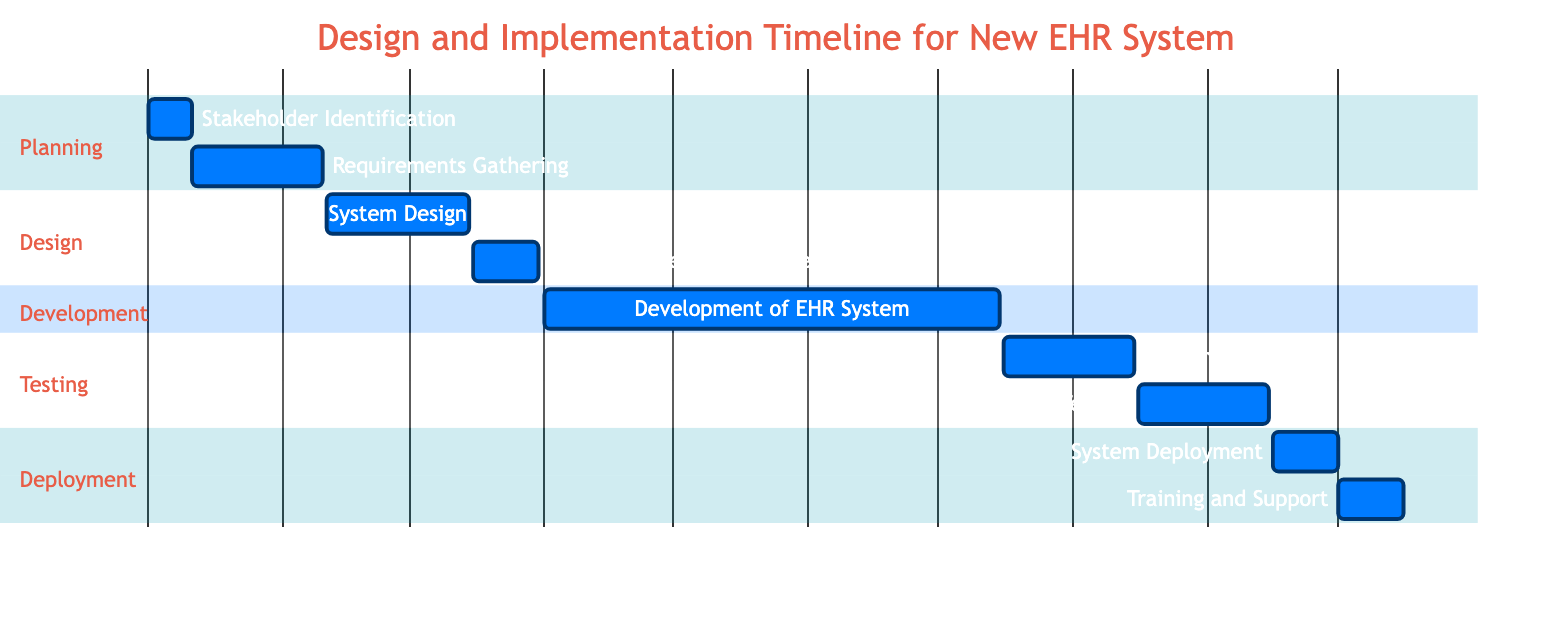What is the duration of the Development of EHR System task? The Development of EHR System task shows a duration of 105 days directly on the diagram.
Answer: 105 days What task follows System Design? Looking at the timeline, the task that follows System Design starts on March 16, which is Technical Specifications Review.
Answer: Technical Specifications Review How many phases are represented in the diagram? The diagram has five distinct sections: Planning, Design, Development, Testing, and Deployment. Counting these sections gives a total of five phases.
Answer: 5 What is the start date for User Acceptance Testing? By inspecting the timeline on the diagram, the User Acceptance Testing task starts on August 16, 2024.
Answer: August 16, 2024 Which task has the longest duration? The Development of EHR System task has the longest duration at 105 days, which is longer than all other tasks in the diagram.
Answer: Development of EHR System Which section does the task Stakeholder Identification belong to? The Stakeholder Identification task is listed in the Planning section, as indicated by its placement in that part of the diagram.
Answer: Planning What is the end date of the System Deployment task? The System Deployment task ends on September 30, 2024, as shown in the timeline of the diagram.
Answer: September 30, 2024 What is the gap between System Testing and User Acceptance Testing? System Testing ends on August 15 and user acceptance testing starts on August 16, indicating no gap between these tasks. They are consecutive.
Answer: 0 days What tasks are part of the Testing section starting from mid-July? The Testing section includes System Testing and User Acceptance Testing, starting from July 16, 2024, and continuing until September 15, 2024.
Answer: System Testing, User Acceptance Testing 